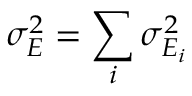<formula> <loc_0><loc_0><loc_500><loc_500>\sigma _ { E } ^ { 2 } = \sum _ { i } \sigma _ { E _ { i } } ^ { 2 }</formula> 